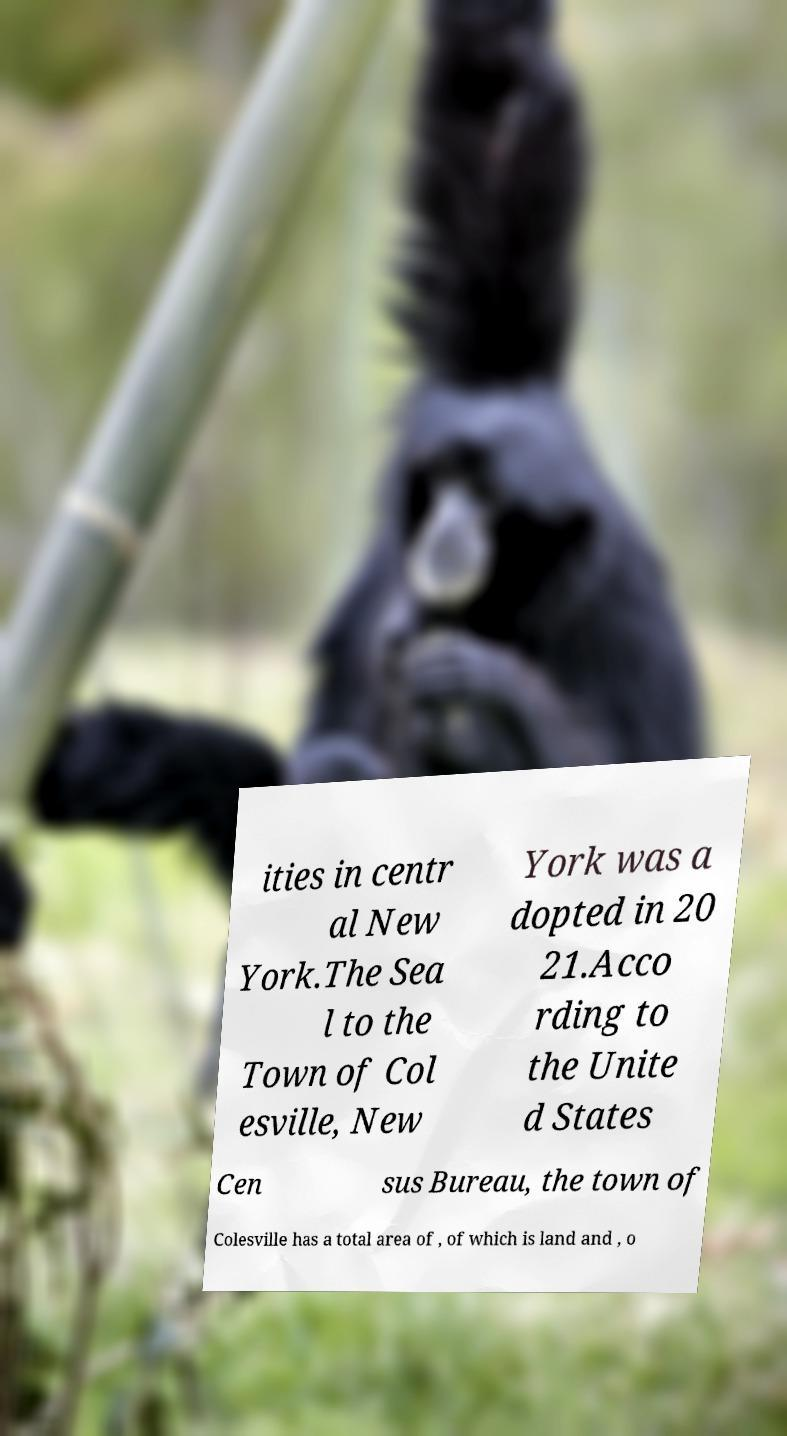Could you extract and type out the text from this image? ities in centr al New York.The Sea l to the Town of Col esville, New York was a dopted in 20 21.Acco rding to the Unite d States Cen sus Bureau, the town of Colesville has a total area of , of which is land and , o 